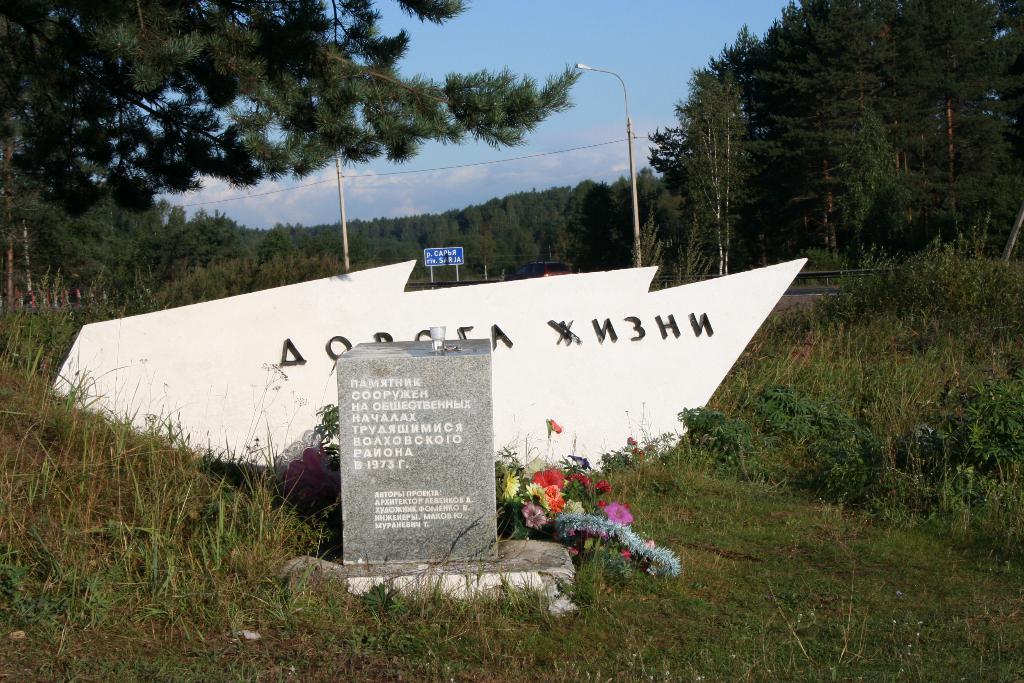Please provide a concise description of this image. In this image we can see trees, there is a head stone on the ground, beside there are flowers, here is the grass, here is the light, here is the pole, at above here is the sky in blue color. 